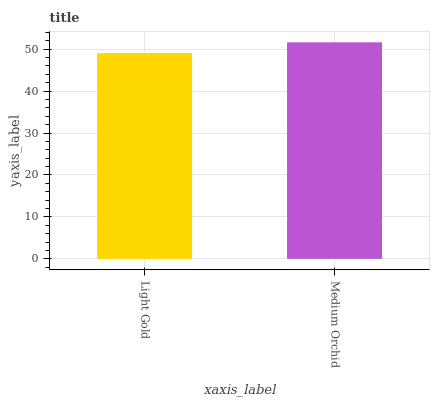Is Light Gold the minimum?
Answer yes or no. Yes. Is Medium Orchid the maximum?
Answer yes or no. Yes. Is Medium Orchid the minimum?
Answer yes or no. No. Is Medium Orchid greater than Light Gold?
Answer yes or no. Yes. Is Light Gold less than Medium Orchid?
Answer yes or no. Yes. Is Light Gold greater than Medium Orchid?
Answer yes or no. No. Is Medium Orchid less than Light Gold?
Answer yes or no. No. Is Medium Orchid the high median?
Answer yes or no. Yes. Is Light Gold the low median?
Answer yes or no. Yes. Is Light Gold the high median?
Answer yes or no. No. Is Medium Orchid the low median?
Answer yes or no. No. 